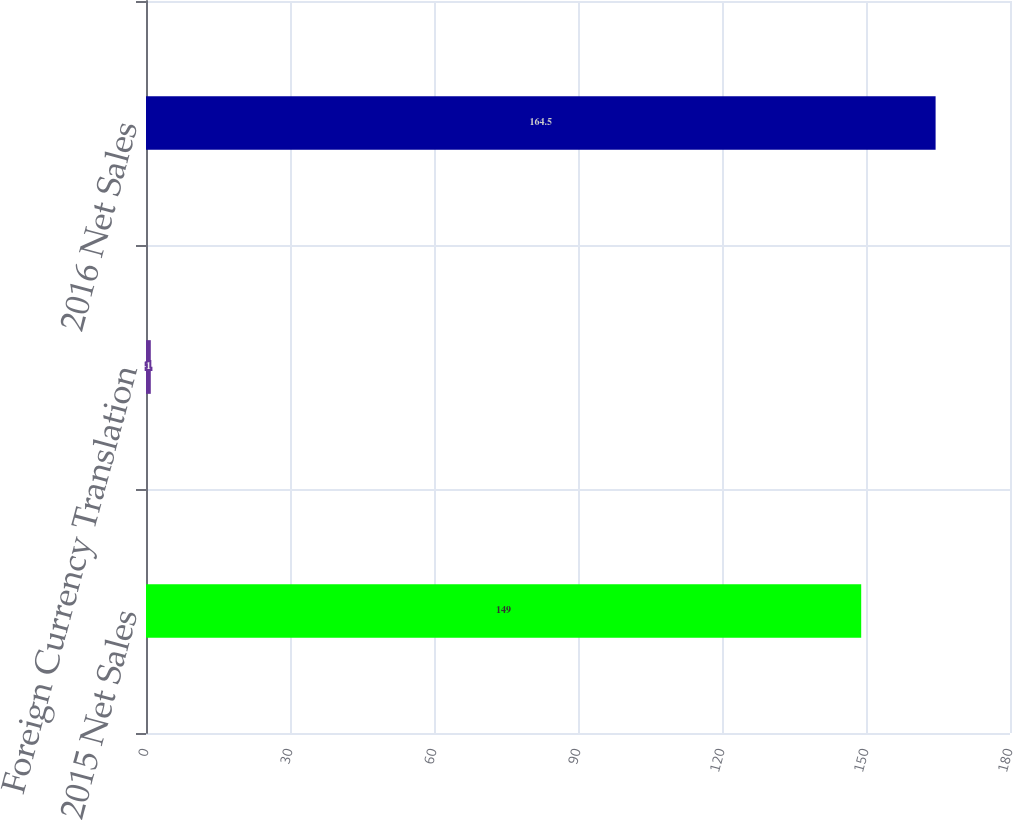<chart> <loc_0><loc_0><loc_500><loc_500><bar_chart><fcel>2015 Net Sales<fcel>Foreign Currency Translation<fcel>2016 Net Sales<nl><fcel>149<fcel>1<fcel>164.5<nl></chart> 